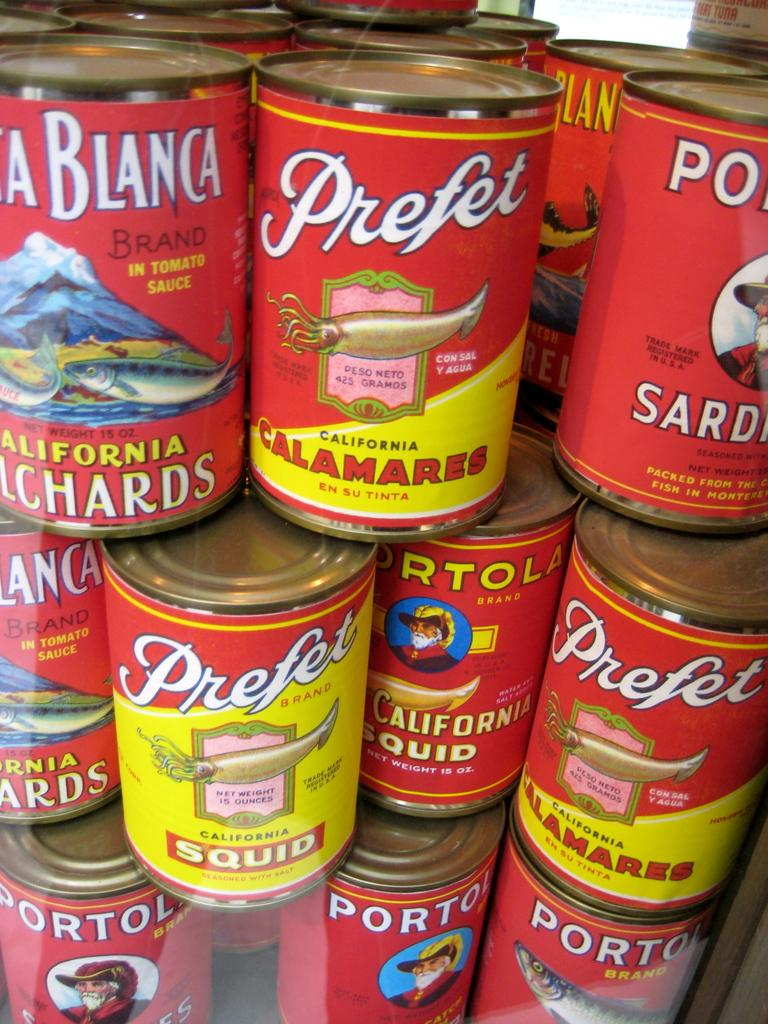<image>
Offer a succinct explanation of the picture presented. Stacked red cans of calamares and squid of the Prefet brand 